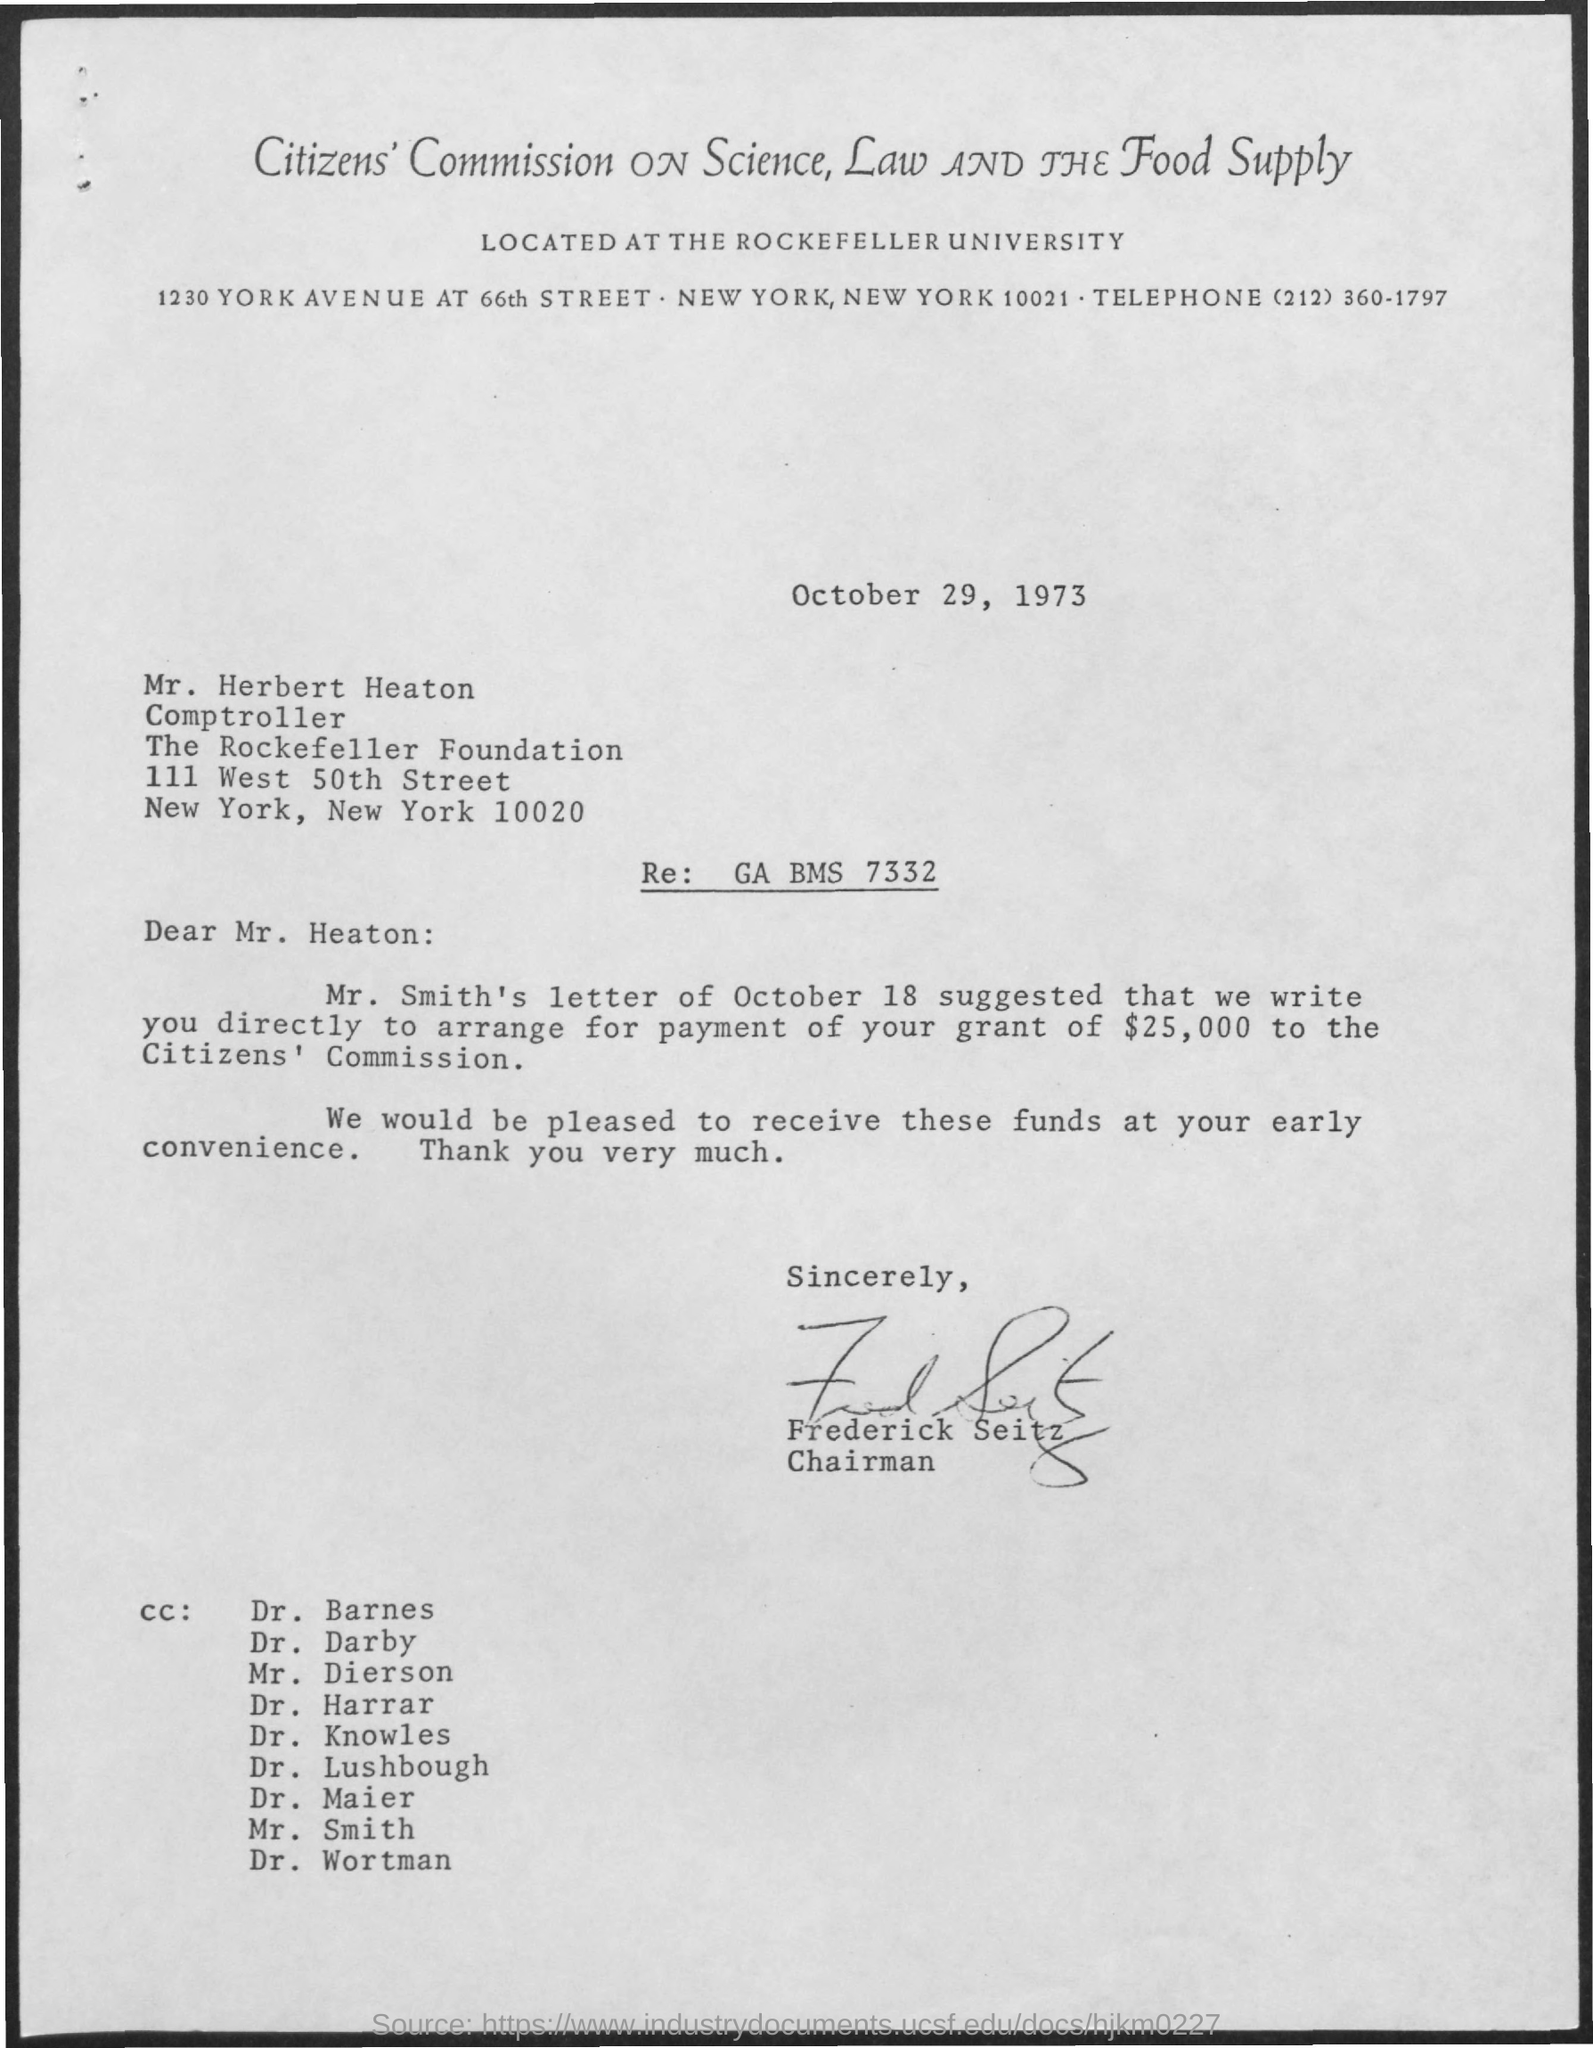What is the date mentioned in the given letter ?
Your answer should be very brief. October 29, 1973. Who's sign was there at the end of the mail ?
Offer a terse response. Frederick Seitz. What is the designation of frederick seitz ?
Keep it short and to the point. Chairman. 